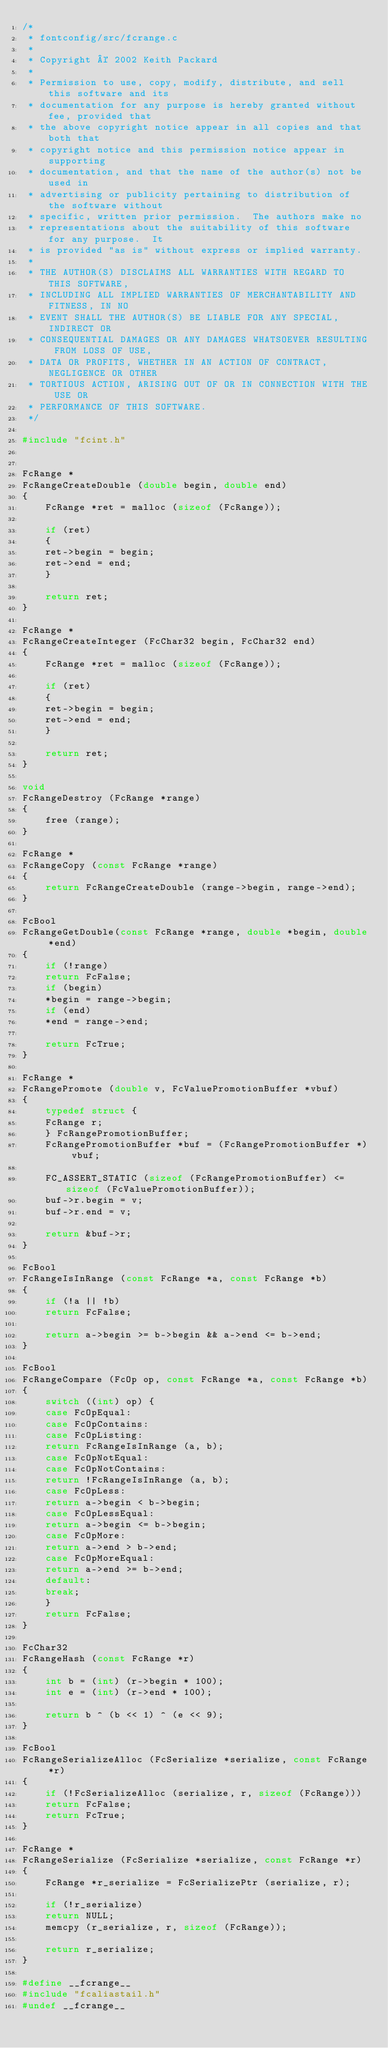Convert code to text. <code><loc_0><loc_0><loc_500><loc_500><_C_>/*
 * fontconfig/src/fcrange.c
 *
 * Copyright © 2002 Keith Packard
 *
 * Permission to use, copy, modify, distribute, and sell this software and its
 * documentation for any purpose is hereby granted without fee, provided that
 * the above copyright notice appear in all copies and that both that
 * copyright notice and this permission notice appear in supporting
 * documentation, and that the name of the author(s) not be used in
 * advertising or publicity pertaining to distribution of the software without
 * specific, written prior permission.  The authors make no
 * representations about the suitability of this software for any purpose.  It
 * is provided "as is" without express or implied warranty.
 *
 * THE AUTHOR(S) DISCLAIMS ALL WARRANTIES WITH REGARD TO THIS SOFTWARE,
 * INCLUDING ALL IMPLIED WARRANTIES OF MERCHANTABILITY AND FITNESS, IN NO
 * EVENT SHALL THE AUTHOR(S) BE LIABLE FOR ANY SPECIAL, INDIRECT OR
 * CONSEQUENTIAL DAMAGES OR ANY DAMAGES WHATSOEVER RESULTING FROM LOSS OF USE,
 * DATA OR PROFITS, WHETHER IN AN ACTION OF CONTRACT, NEGLIGENCE OR OTHER
 * TORTIOUS ACTION, ARISING OUT OF OR IN CONNECTION WITH THE USE OR
 * PERFORMANCE OF THIS SOFTWARE.
 */

#include "fcint.h"


FcRange *
FcRangeCreateDouble (double begin, double end)
{
    FcRange *ret = malloc (sizeof (FcRange));

    if (ret)
    {
	ret->begin = begin;
	ret->end = end;
    }

    return ret;
}

FcRange *
FcRangeCreateInteger (FcChar32 begin, FcChar32 end)
{
    FcRange *ret = malloc (sizeof (FcRange));

    if (ret)
    {
	ret->begin = begin;
	ret->end = end;
    }

    return ret;
}

void
FcRangeDestroy (FcRange *range)
{
    free (range);
}

FcRange *
FcRangeCopy (const FcRange *range)
{
    return FcRangeCreateDouble (range->begin, range->end);
}

FcBool
FcRangeGetDouble(const FcRange *range, double *begin, double *end)
{
    if (!range)
	return FcFalse;
    if (begin)
	*begin = range->begin;
    if (end)
	*end = range->end;

    return FcTrue;
}

FcRange *
FcRangePromote (double v, FcValuePromotionBuffer *vbuf)
{
    typedef struct {
	FcRange	r;
    } FcRangePromotionBuffer;
    FcRangePromotionBuffer *buf = (FcRangePromotionBuffer *) vbuf;

    FC_ASSERT_STATIC (sizeof (FcRangePromotionBuffer) <= sizeof (FcValuePromotionBuffer));
    buf->r.begin = v;
    buf->r.end = v;

    return &buf->r;
}

FcBool
FcRangeIsInRange (const FcRange *a, const FcRange *b)
{
    if (!a || !b)
	return FcFalse;

    return a->begin >= b->begin && a->end <= b->end;
}

FcBool
FcRangeCompare (FcOp op, const FcRange *a, const FcRange *b)
{
    switch ((int) op) {
    case FcOpEqual:
    case FcOpContains:
    case FcOpListing:
	return FcRangeIsInRange (a, b);
    case FcOpNotEqual:
    case FcOpNotContains:
	return !FcRangeIsInRange (a, b);
    case FcOpLess:
	return a->begin < b->begin;
    case FcOpLessEqual:
	return a->begin <= b->begin;
    case FcOpMore:
	return a->end > b->end;
    case FcOpMoreEqual:
	return a->end >= b->end;
    default:
	break;
    }
    return FcFalse;
}

FcChar32
FcRangeHash (const FcRange *r)
{
    int b = (int) (r->begin * 100);
    int e = (int) (r->end * 100);

    return b ^ (b << 1) ^ (e << 9);
}

FcBool
FcRangeSerializeAlloc (FcSerialize *serialize, const FcRange *r)
{
    if (!FcSerializeAlloc (serialize, r, sizeof (FcRange)))
	return FcFalse;
    return FcTrue;
}

FcRange *
FcRangeSerialize (FcSerialize *serialize, const FcRange *r)
{
    FcRange *r_serialize = FcSerializePtr (serialize, r);

    if (!r_serialize)
	return NULL;
    memcpy (r_serialize, r, sizeof (FcRange));

    return r_serialize;
}

#define __fcrange__
#include "fcaliastail.h"
#undef __fcrange__
</code> 